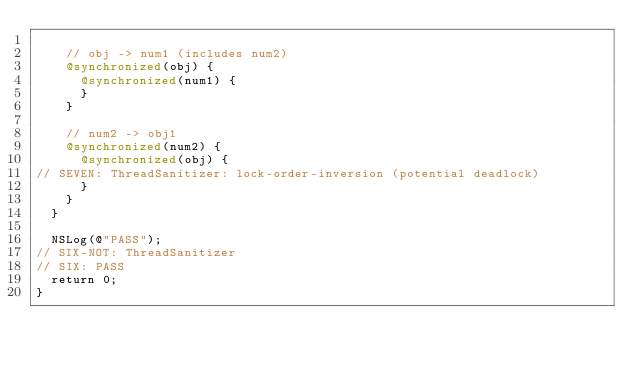<code> <loc_0><loc_0><loc_500><loc_500><_ObjectiveC_>
    // obj -> num1 (includes num2)
    @synchronized(obj) {
      @synchronized(num1) {
      }
    }

    // num2 -> obj1
    @synchronized(num2) {
      @synchronized(obj) {
// SEVEN: ThreadSanitizer: lock-order-inversion (potential deadlock)
      }
    }
  }

  NSLog(@"PASS");
// SIX-NOT: ThreadSanitizer
// SIX: PASS
  return 0;
}
</code> 